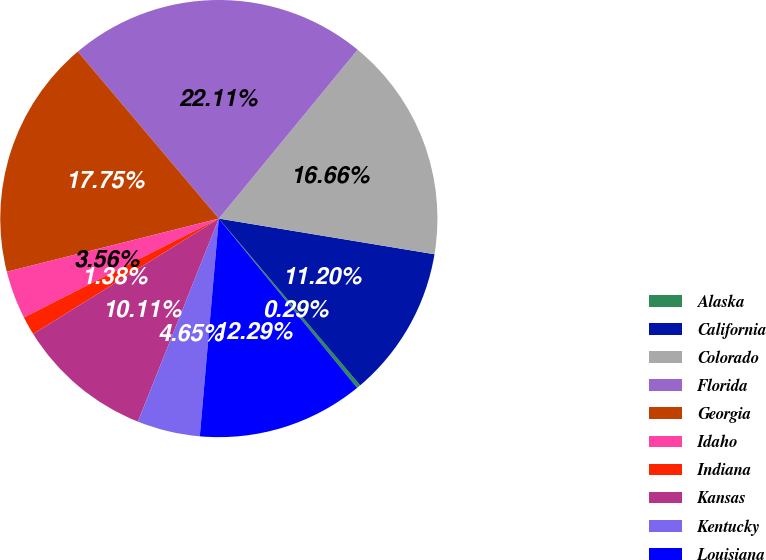Convert chart. <chart><loc_0><loc_0><loc_500><loc_500><pie_chart><fcel>Alaska<fcel>California<fcel>Colorado<fcel>Florida<fcel>Georgia<fcel>Idaho<fcel>Indiana<fcel>Kansas<fcel>Kentucky<fcel>Louisiana<nl><fcel>0.29%<fcel>11.2%<fcel>16.66%<fcel>22.11%<fcel>17.75%<fcel>3.56%<fcel>1.38%<fcel>10.11%<fcel>4.65%<fcel>12.29%<nl></chart> 